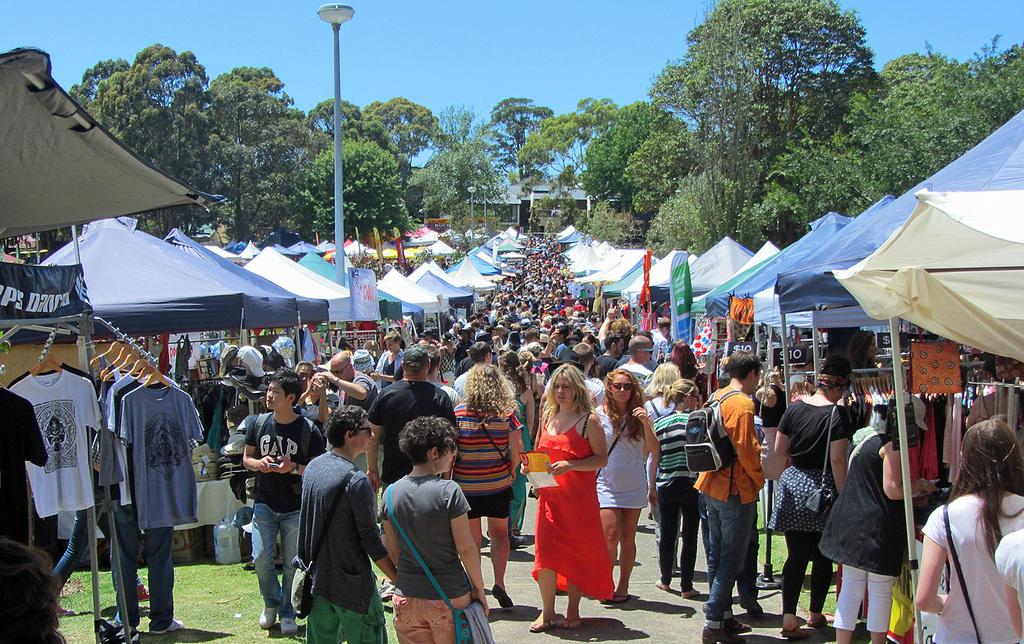What is happening with the group of people in the image? The group of people is on the ground in the image. What type of temporary shelters can be seen in the image? There are tents in the image. What else is visible in the image besides the people and tents? Clothes and electric poles with lights are visible in the image. Can you describe the objects in the image? There are some objects in the image, but their specific nature is not clear from the provided facts. What can be seen in the background of the image? There are trees and the sky visible in the background of the image. What type of twig is being used by the carpenter in the image? There is no carpenter or twig present in the image. What rule is being enforced by the person holding the rule in the image? There is no person holding a rule in the image. 